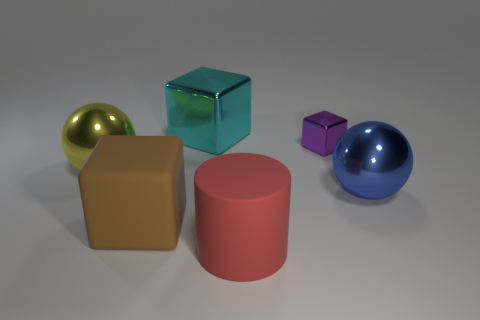Which objects in the image appear to have a texture and which are smooth? Most objects in the image appear to have a smooth surface, particularly the spheres and the cube. The rubber block and the cylinder might have a slightly matte or textured finish, but it's less noticeable compared to the shiny quality of the other objects. 